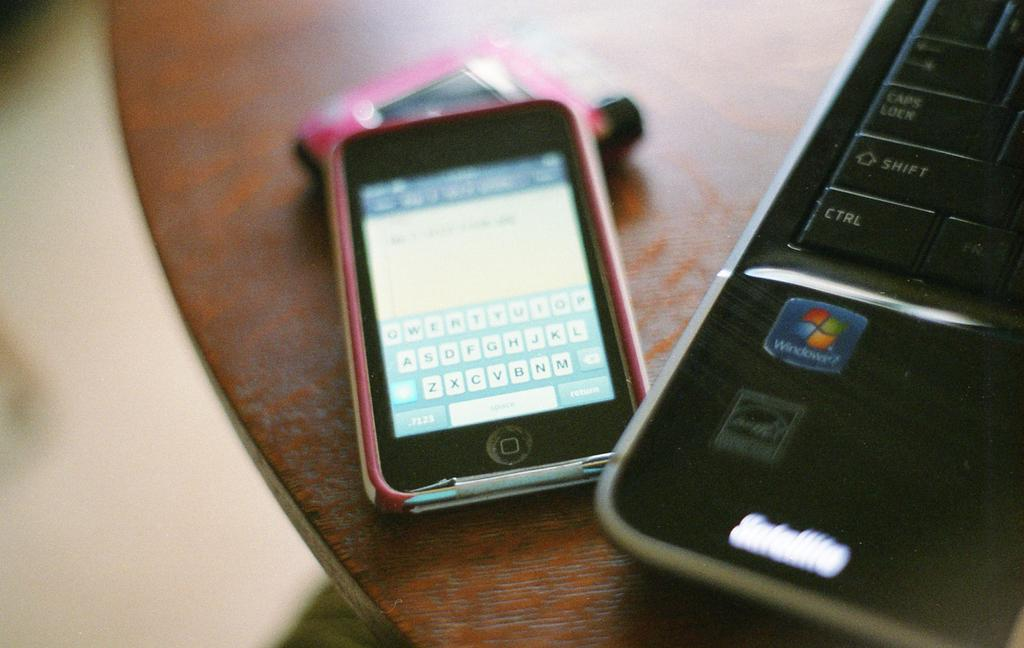Provide a one-sentence caption for the provided image. A phone next to a laptop that runs Windows. 